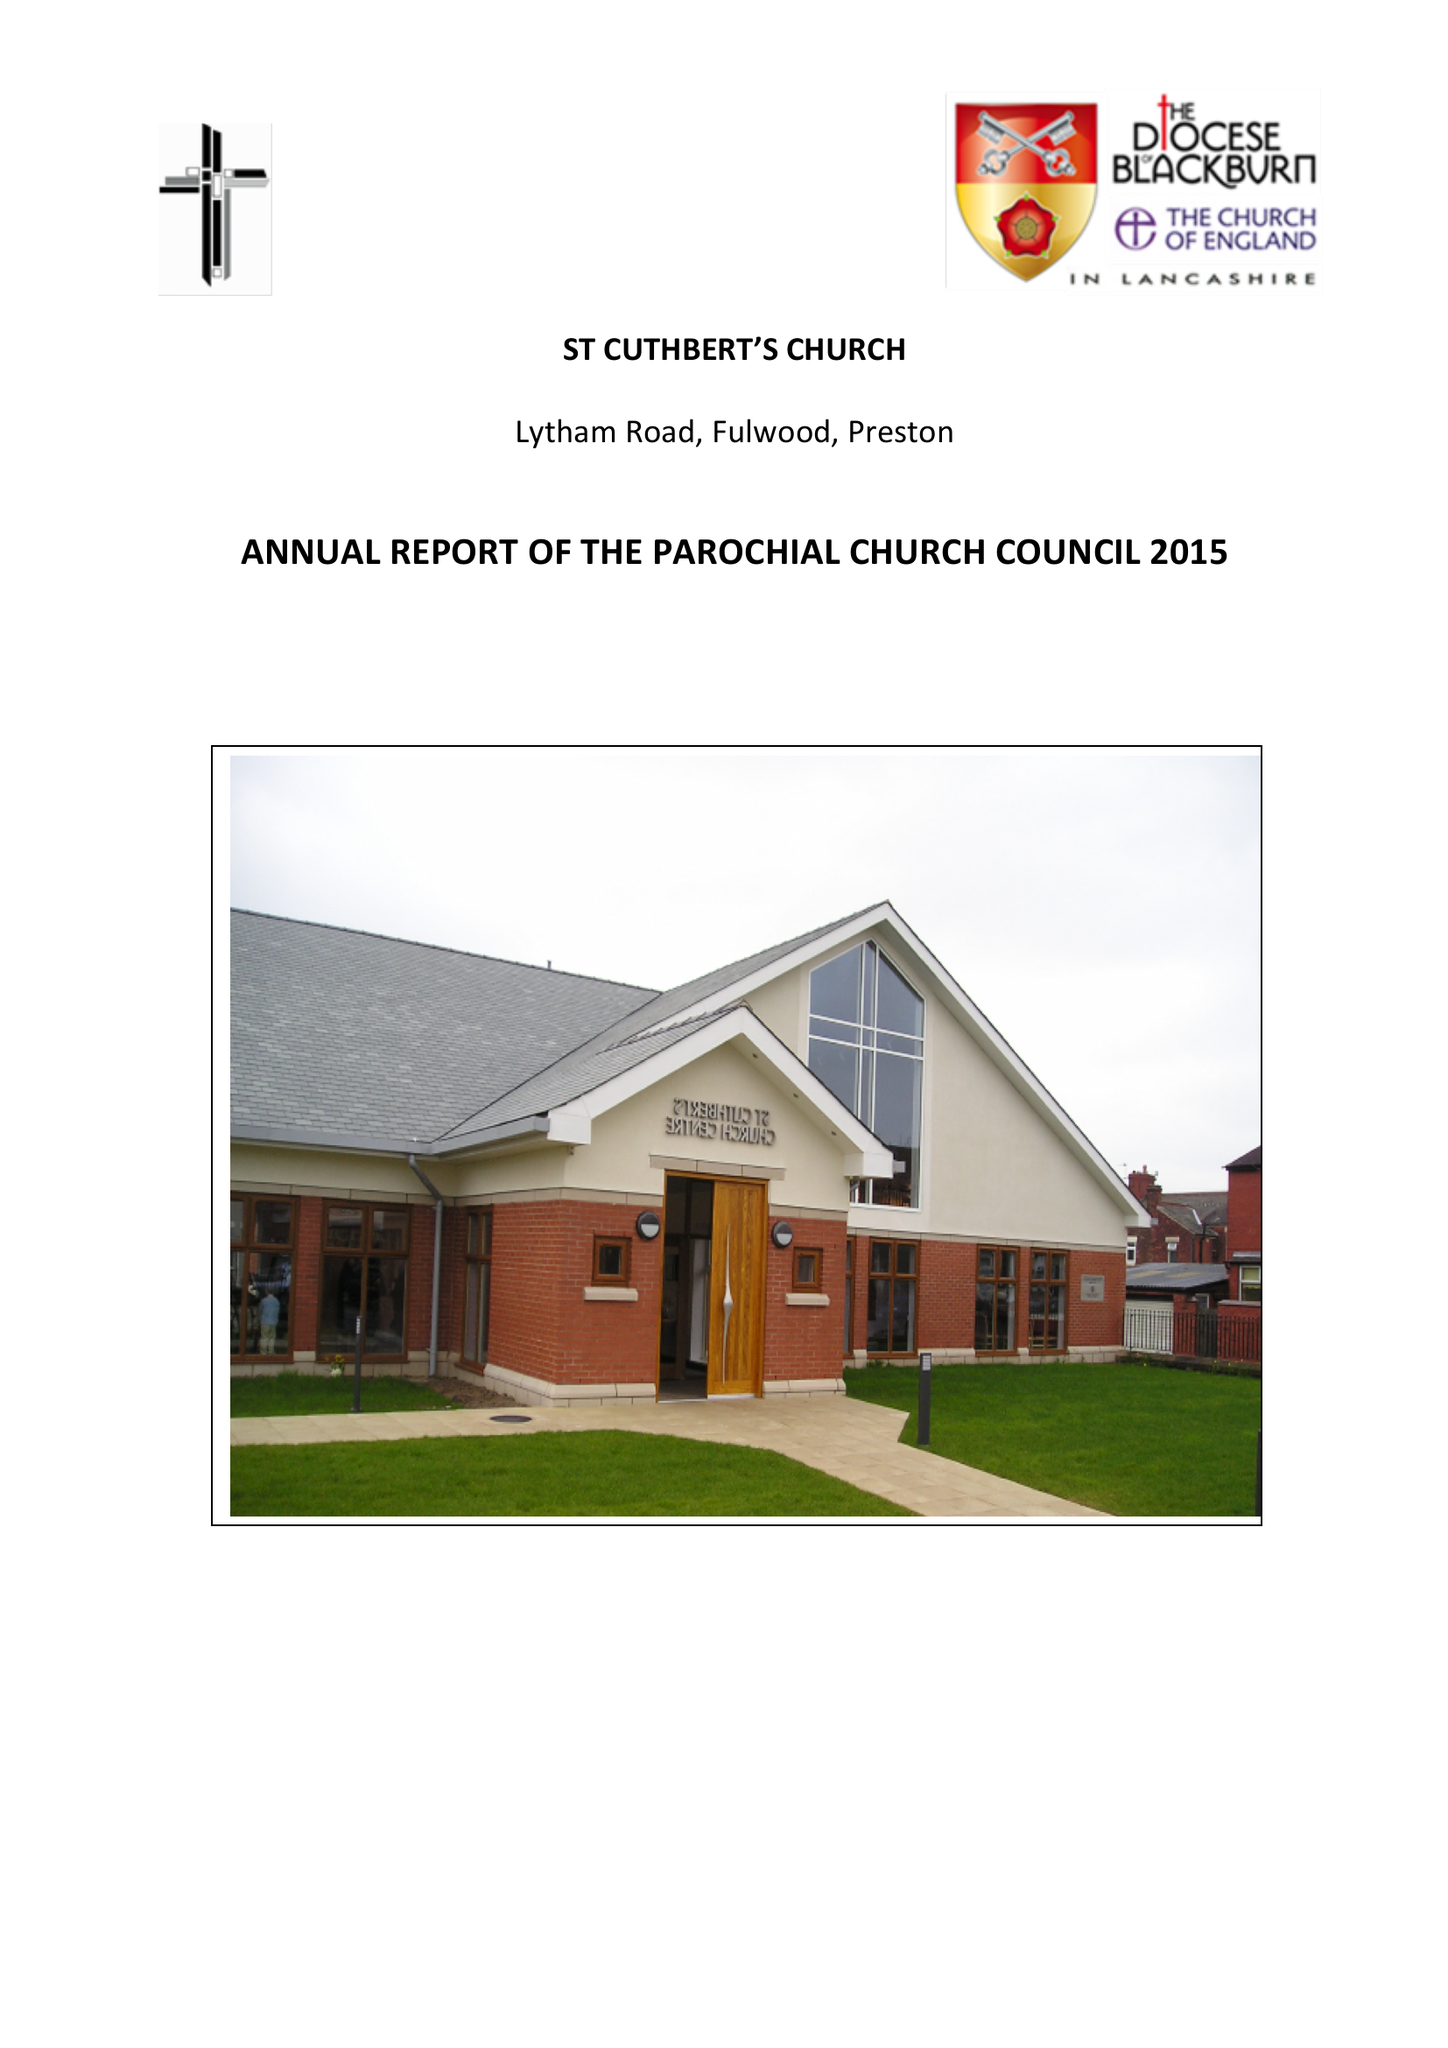What is the value for the report_date?
Answer the question using a single word or phrase. 2015-12-31 